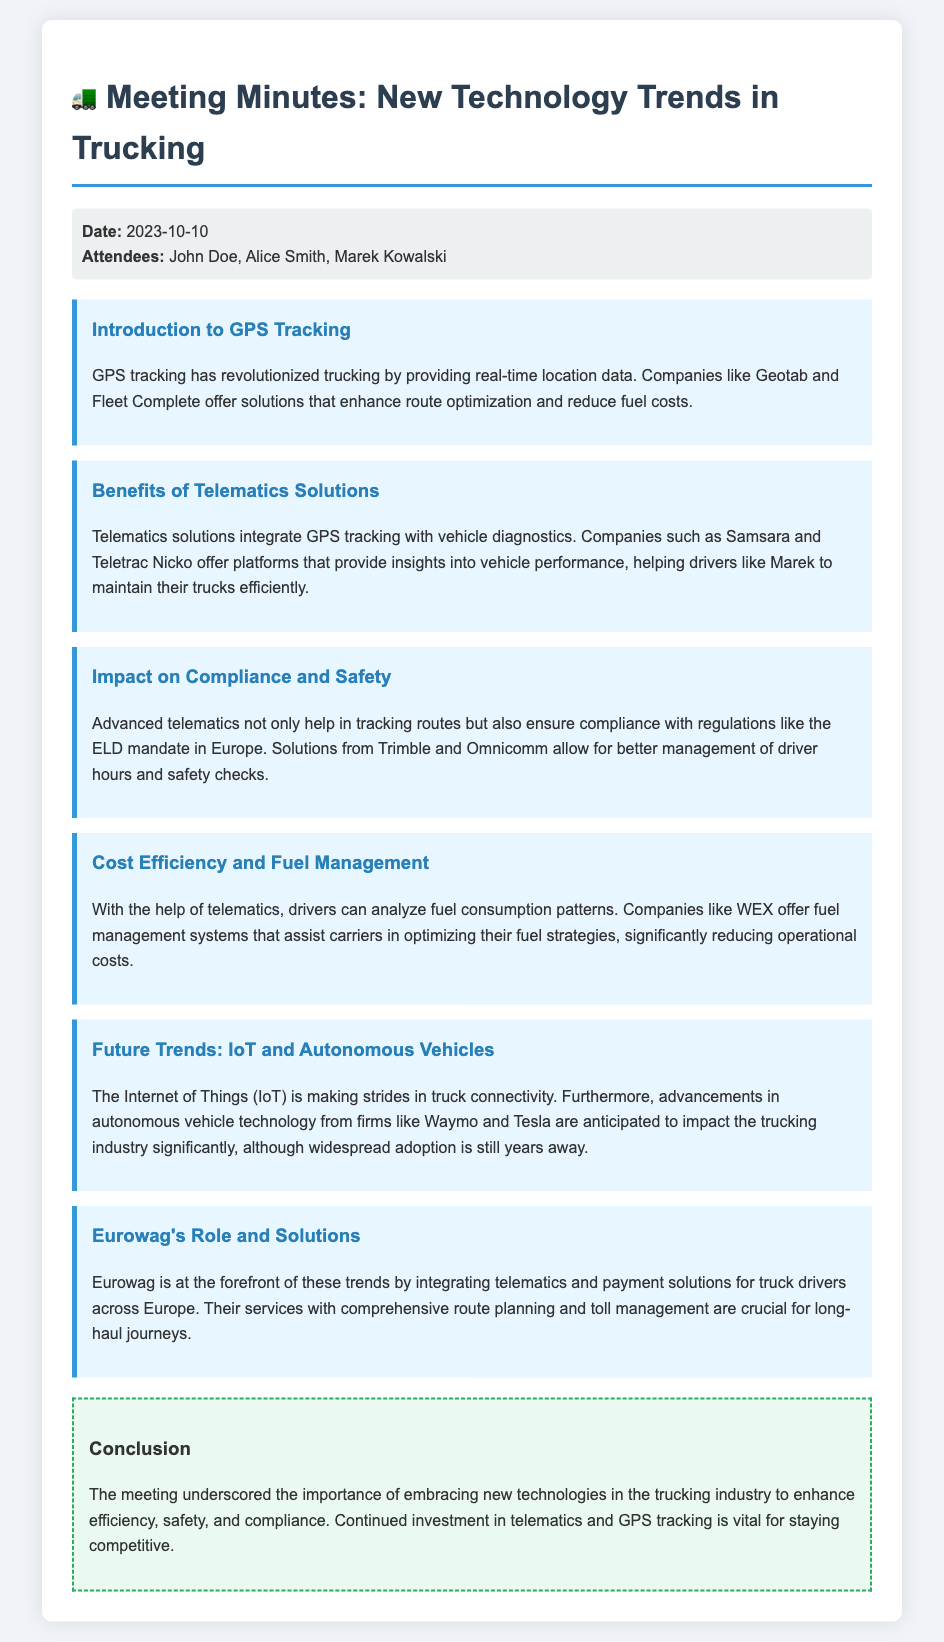What is the date of the meeting? The date of the meeting is found in the document under the "Date" section.
Answer: 2023-10-10 Who is one of the attendees? The attendees of the meeting are listed in the "Attendees" section of the document.
Answer: Marek Kowalski What technology has revolutionized trucking according to the document? The document specifically states that GPS tracking has revolutionized trucking.
Answer: GPS tracking Which company offers fuel management systems? The document mentions a specific company that provides fuel management solutions in the "Cost Efficiency and Fuel Management" key point.
Answer: WEX What does Eurowag provide for truck drivers? The document highlights Eurowag's role in providing solutions for truck drivers in the final key point.
Answer: telematics and payment solutions What is the main focus of the meeting's conclusion? The conclusion summarizes the emphasis on a particular aspect of technology in the trucking industry.
Answer: embracing new technologies Which company is associated with autonomous vehicles in the document? The document lists companies involved in autonomous vehicle technology in the "Future Trends" section.
Answer: Waymo How many key points are discussed in the document? The number of key points can be counted in the "key points" section of the document.
Answer: Six 